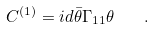<formula> <loc_0><loc_0><loc_500><loc_500>C ^ { \left ( 1 \right ) } = i d \bar { \theta } \Gamma _ { 1 1 } \theta \quad .</formula> 